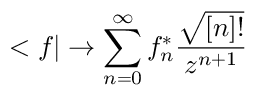<formula> <loc_0><loc_0><loc_500><loc_500>< f | \rightarrow \sum _ { n = 0 } ^ { \infty } f _ { n } ^ { * } \frac { \sqrt { [ n ] ! } } { z ^ { n + 1 } }</formula> 